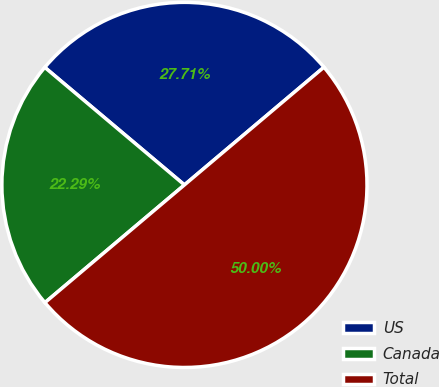<chart> <loc_0><loc_0><loc_500><loc_500><pie_chart><fcel>US<fcel>Canada<fcel>Total<nl><fcel>27.71%<fcel>22.29%<fcel>50.0%<nl></chart> 